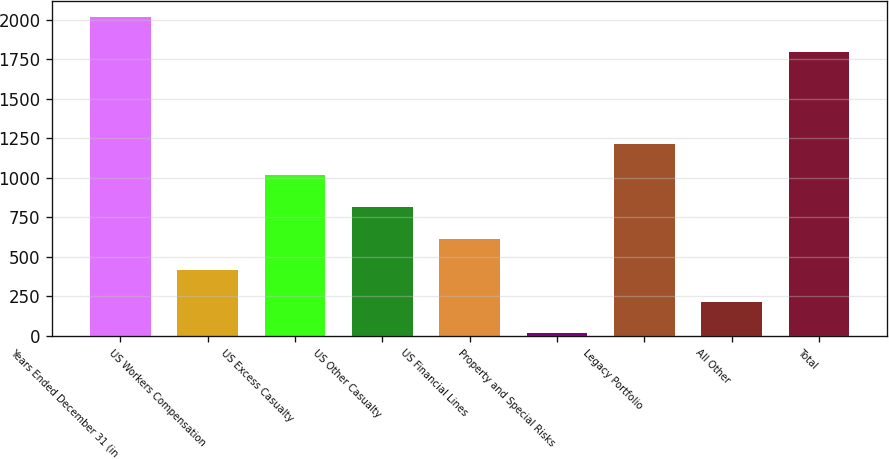Convert chart. <chart><loc_0><loc_0><loc_500><loc_500><bar_chart><fcel>Years Ended December 31 (in<fcel>US Workers Compensation<fcel>US Excess Casualty<fcel>US Other Casualty<fcel>US Financial Lines<fcel>Property and Special Risks<fcel>Legacy Portfolio<fcel>All Other<fcel>Total<nl><fcel>2015<fcel>415.8<fcel>1015.5<fcel>815.6<fcel>615.7<fcel>16<fcel>1215.4<fcel>215.9<fcel>1798<nl></chart> 